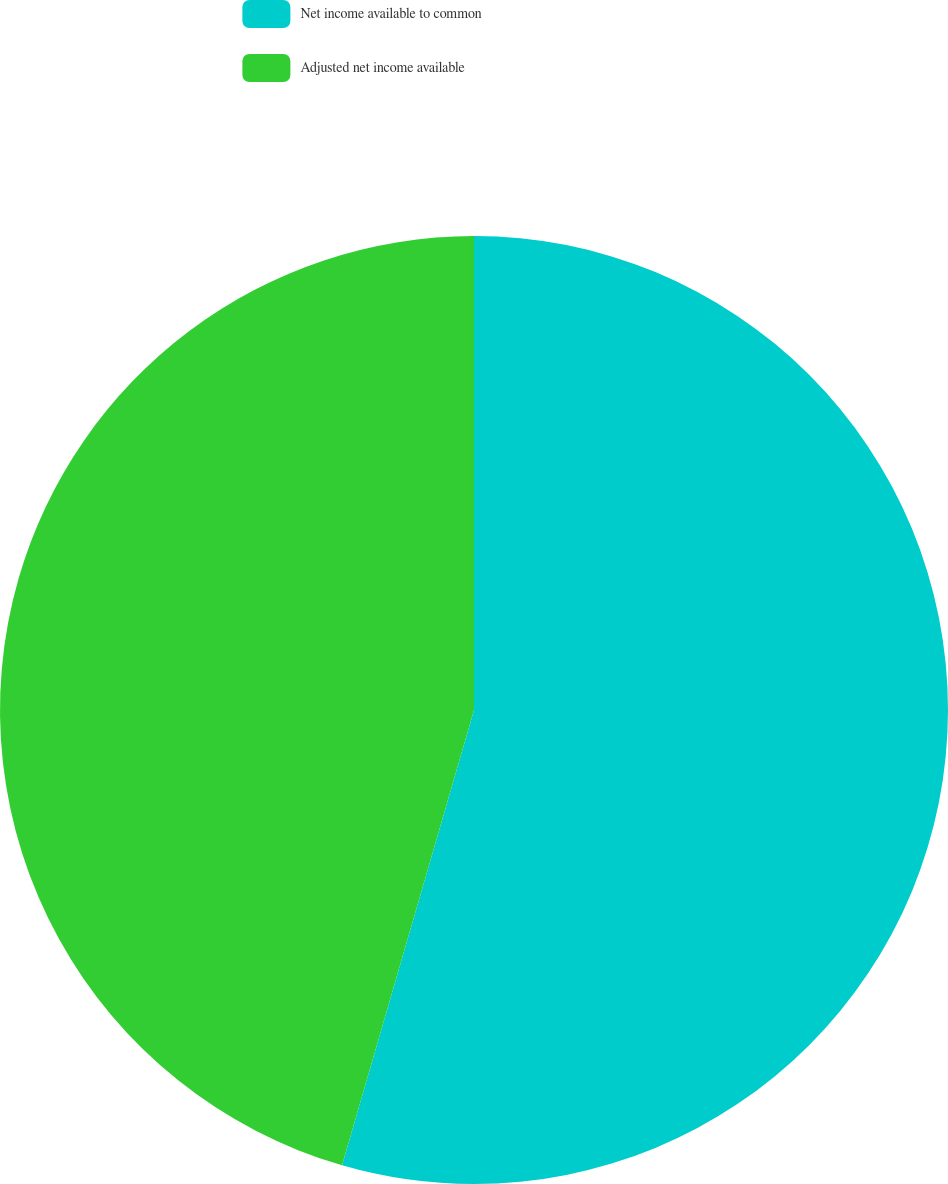<chart> <loc_0><loc_0><loc_500><loc_500><pie_chart><fcel>Net income available to common<fcel>Adjusted net income available<nl><fcel>54.49%<fcel>45.51%<nl></chart> 